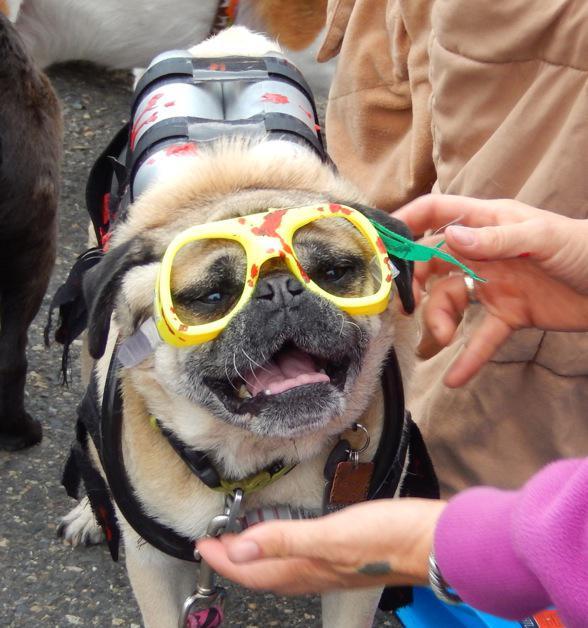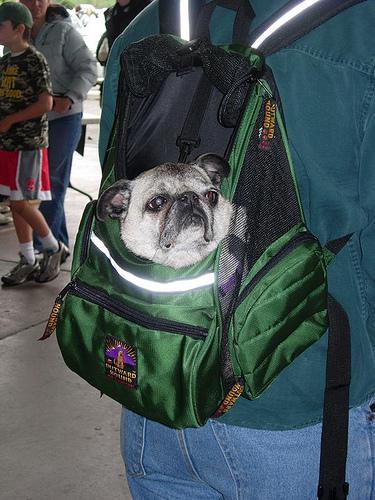The first image is the image on the left, the second image is the image on the right. For the images displayed, is the sentence "a pug is dressed in a costime" factually correct? Answer yes or no. Yes. The first image is the image on the left, the second image is the image on the right. Considering the images on both sides, is "One of the dogs is dressed in a costume and the other dog's head is hanging out of a backpack." valid? Answer yes or no. Yes. 